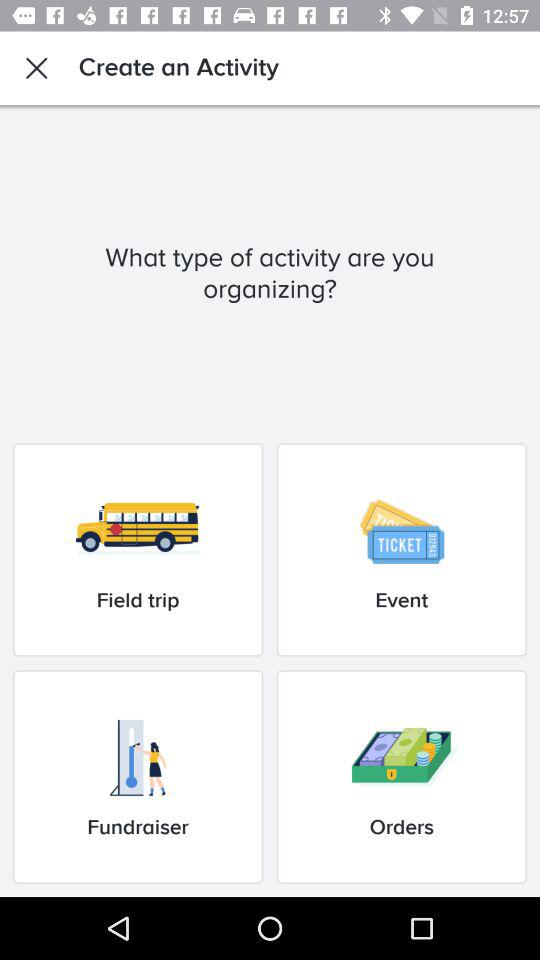What are the activities which are stated to be organized? The activities "Field trip", "Event", "Fundraiser" and "Orders" are stated to be organized. 